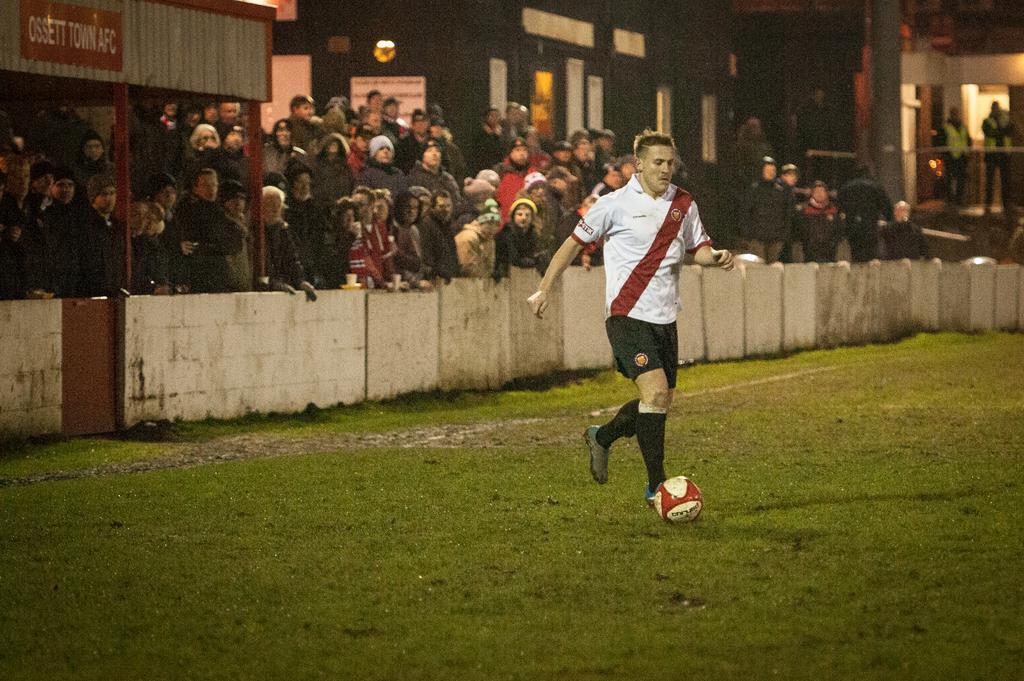Could you give a brief overview of what you see in this image? In this picture we can see crowd of people looking at a person hitting ball on ground and in background we can see building with windows, pillar, fence. 